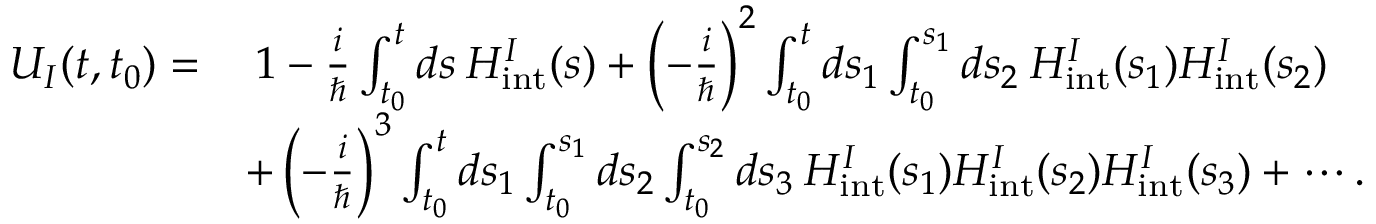<formula> <loc_0><loc_0><loc_500><loc_500>\begin{array} { r l } { U _ { I } ( t , t _ { 0 } ) = } & { \, 1 - \frac { i } { } \int _ { t _ { 0 } } ^ { t } d s \, H _ { i n t } ^ { I } ( s ) + \left ( - \frac { i } { } \right ) ^ { 2 } \int _ { t _ { 0 } } ^ { t } d s _ { 1 } \int _ { t _ { 0 } } ^ { s _ { 1 } } d s _ { 2 } \, H _ { i n t } ^ { I } ( s _ { 1 } ) H _ { i n t } ^ { I } ( s _ { 2 } ) } \\ & { + \left ( - \frac { i } { } \right ) ^ { 3 } \int _ { t _ { 0 } } ^ { t } d s _ { 1 } \int _ { t _ { 0 } } ^ { s _ { 1 } } d s _ { 2 } \int _ { t _ { 0 } } ^ { s _ { 2 } } d s _ { 3 } \, H _ { i n t } ^ { I } ( s _ { 1 } ) H _ { i n t } ^ { I } ( s _ { 2 } ) H _ { i n t } ^ { I } ( s _ { 3 } ) + \cdots . } \end{array}</formula> 